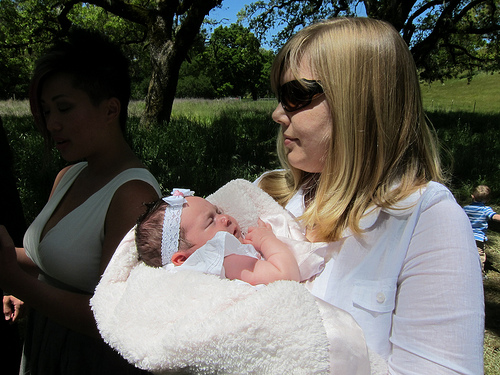<image>
Is the baby next to the lady? Yes. The baby is positioned adjacent to the lady, located nearby in the same general area. 